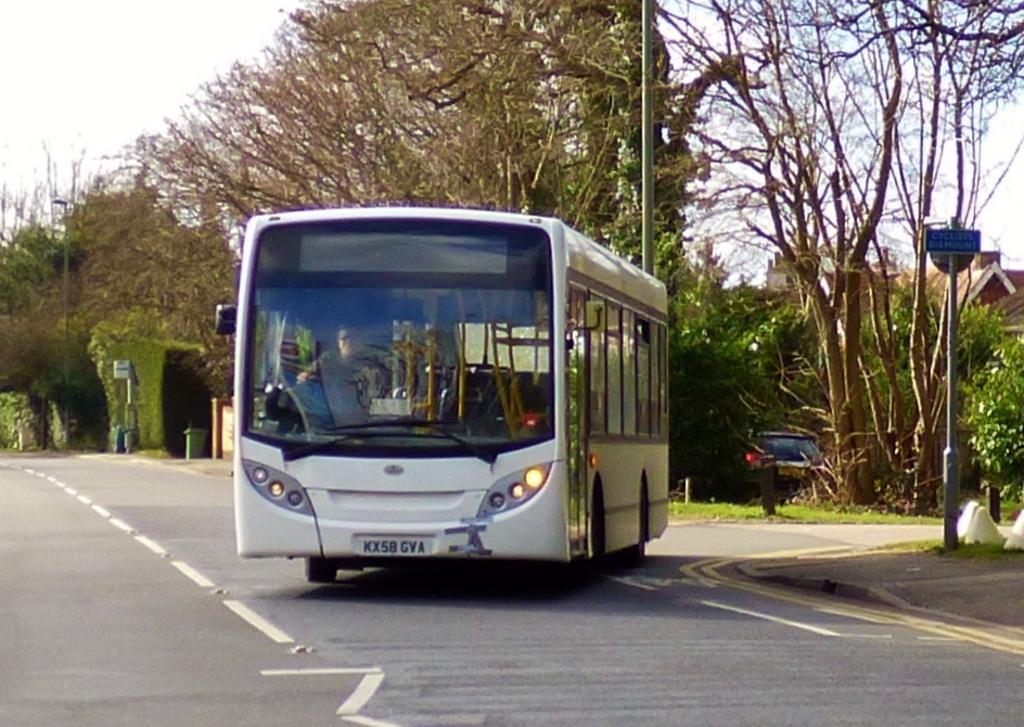Describe this image in one or two sentences. This is an outside view. Here I can see a white color bus on the road. Inside the bus one person is sitting. On both sides of the road I can see the poles. In the background there are trees and I can see a car. On the top of the image I can see the sky. 